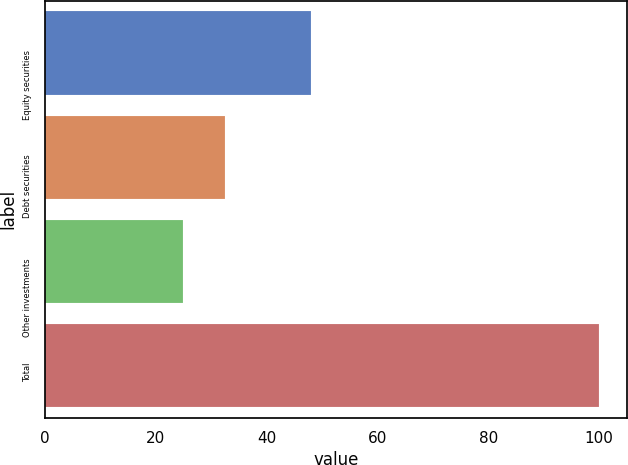Convert chart. <chart><loc_0><loc_0><loc_500><loc_500><bar_chart><fcel>Equity securities<fcel>Debt securities<fcel>Other investments<fcel>Total<nl><fcel>48<fcel>32.5<fcel>25<fcel>100<nl></chart> 